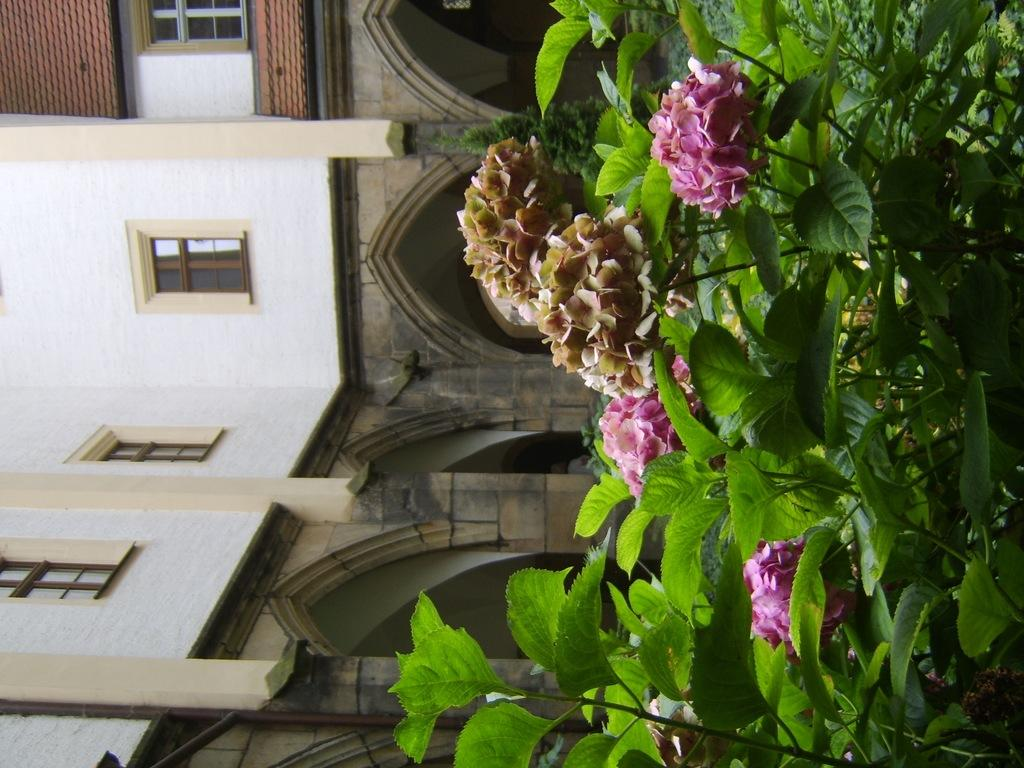What type of vegetation is present on the right side of the image? There are plants and flowers on the right side of the image. What type of structure is visible on the left side of the image? There is a building on the left side of the image. What type of sheet is draped over the curtain in the image? There is no sheet or curtain present in the image. What color is the wall behind the plants in the image? The provided facts do not mention a wall behind the plants, so we cannot determine its color. 